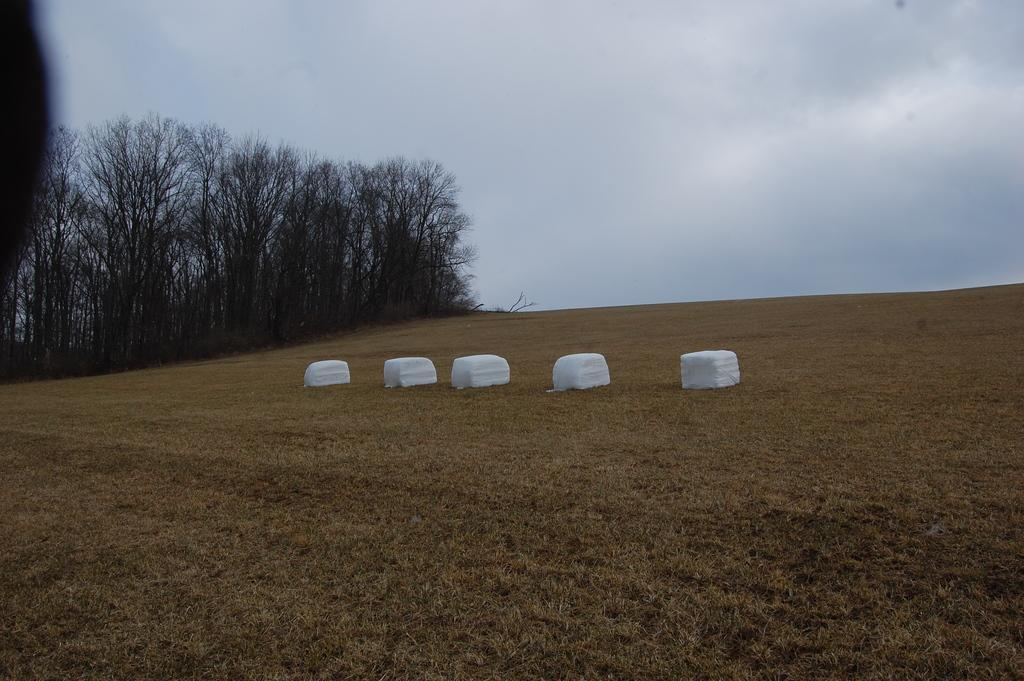What type of vegetation is at the bottom of the image? There is dry grass at the bottom of the image. What can be seen in the center of the image? There are white color objects in the center of the image. What is visible in the background of the image? There are trees in the background of the image. What part of the natural environment is visible in the image? The sky is visible in the image. Can you tell me how many kettles are present in the image? There is no kettle present in the image. What type of dust can be seen on the white objects in the image? There is no dust visible on the white objects in the image. 